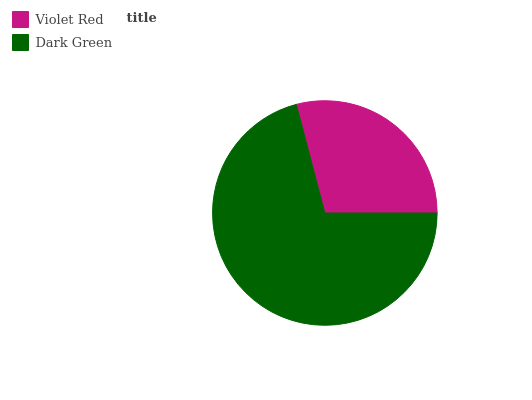Is Violet Red the minimum?
Answer yes or no. Yes. Is Dark Green the maximum?
Answer yes or no. Yes. Is Dark Green the minimum?
Answer yes or no. No. Is Dark Green greater than Violet Red?
Answer yes or no. Yes. Is Violet Red less than Dark Green?
Answer yes or no. Yes. Is Violet Red greater than Dark Green?
Answer yes or no. No. Is Dark Green less than Violet Red?
Answer yes or no. No. Is Dark Green the high median?
Answer yes or no. Yes. Is Violet Red the low median?
Answer yes or no. Yes. Is Violet Red the high median?
Answer yes or no. No. Is Dark Green the low median?
Answer yes or no. No. 